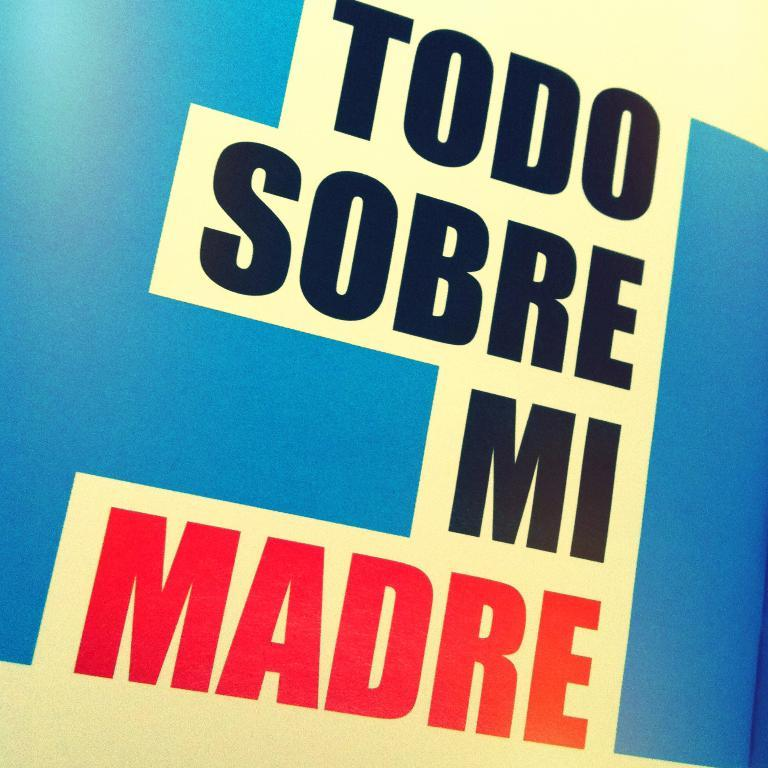<image>
Write a terse but informative summary of the picture. A blue, white, and red poster says Todo Sobre Mi Madre. 